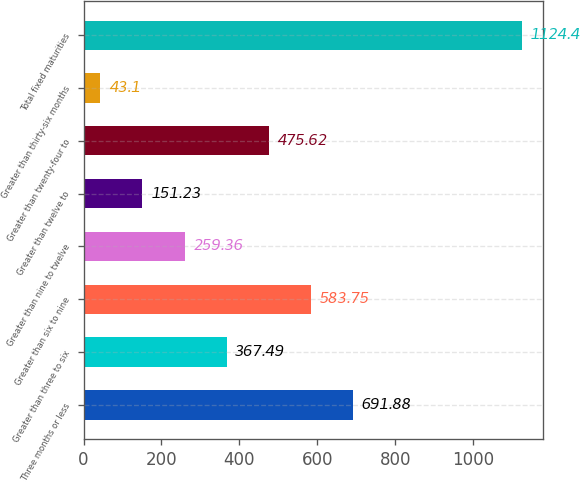Convert chart. <chart><loc_0><loc_0><loc_500><loc_500><bar_chart><fcel>Three months or less<fcel>Greater than three to six<fcel>Greater than six to nine<fcel>Greater than nine to twelve<fcel>Greater than twelve to<fcel>Greater than twenty-four to<fcel>Greater than thirty-six months<fcel>Total fixed maturities<nl><fcel>691.88<fcel>367.49<fcel>583.75<fcel>259.36<fcel>151.23<fcel>475.62<fcel>43.1<fcel>1124.4<nl></chart> 